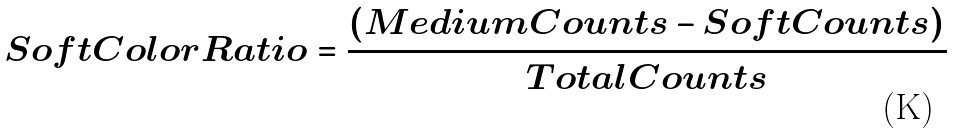<formula> <loc_0><loc_0><loc_500><loc_500>S o f t C o l o r R a t i o = \frac { ( M e d i u m C o u n t s - S o f t C o u n t s ) } { T o t a l C o u n t s }</formula> 